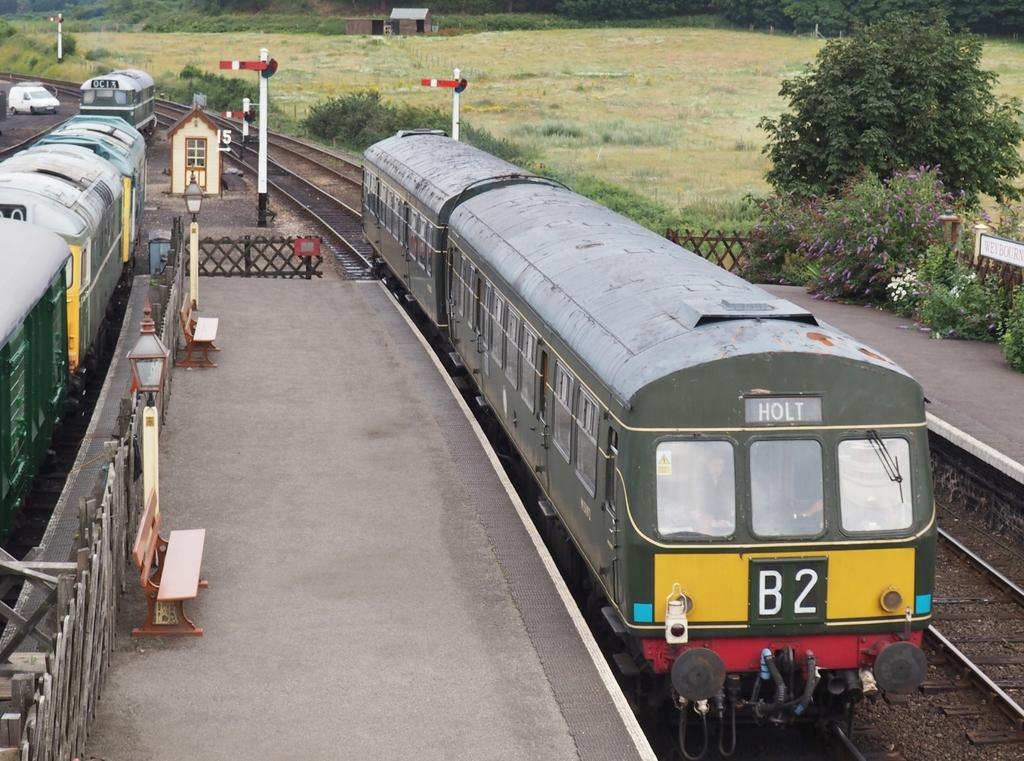<image>
Describe the image concisely. A blue and yellow train has the number B2 on its back side. 